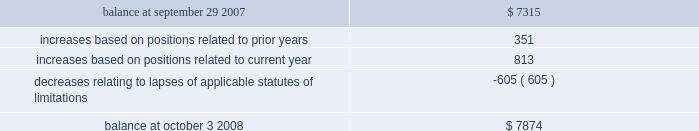Notes to consolidated financial statements 2014 ( continued ) a reconciliation of the beginning and ending amount of gross unrecognized tax benefits is as follows ( in thousands ) : .
The company 2019s major tax jurisdictions as of october 3 , 2008 for fin 48 are the u.s. , california , and iowa .
For the u.s. , the company has open tax years dating back to fiscal year 1998 due to the carryforward of tax attributes .
For california , the company has open tax years dating back to fiscal year 2002 due to the carryforward of tax attributes .
For iowa , the company has open tax years dating back to fiscal year 2002 due to the carryforward of tax attributes .
During the year ended october 3 , 2008 , the statute of limitations period expired relating to an unrecognized tax benefit .
The expiration of the statute of limitations period resulted in the recognition of $ 0.6 million of previously unrecognized tax benefit , which impacted the effective tax rate , and $ 0.5 million of accrued interest related to this tax position was reversed during the year .
Including this reversal , total year-to-date accrued interest related to the company 2019s unrecognized tax benefits was a benefit of $ 0.4 million .
10 .
Stockholders 2019 equity common stock the company is authorized to issue ( 1 ) 525000000 shares of common stock , par value $ 0.25 per share , and ( 2 ) 25000000 shares of preferred stock , without par value .
Holders of the company 2019s common stock are entitled to such dividends as may be declared by the company 2019s board of directors out of funds legally available for such purpose .
Dividends may not be paid on common stock unless all accrued dividends on preferred stock , if any , have been paid or declared and set aside .
In the event of the company 2019s liquidation , dissolution or winding up , the holders of common stock will be entitled to share pro rata in the assets remaining after payment to creditors and after payment of the liquidation preference plus any unpaid dividends to holders of any outstanding preferred stock .
Each holder of the company 2019s common stock is entitled to one vote for each such share outstanding in the holder 2019s name .
No holder of common stock is entitled to cumulate votes in voting for directors .
The company 2019s second amended and restated certificate of incorporation provides that , unless otherwise determined by the company 2019s board of directors , no holder of common stock has any preemptive right to purchase or subscribe for any stock of any class which the company may issue or sell .
In march 2007 , the company repurchased approximately 4.3 million of its common shares for $ 30.1 million as authorized by the company 2019s board of directors .
The company has no publicly disclosed stock repurchase plans .
At october 3 , 2008 , the company had 170322804 shares of common stock issued and 165591830 shares outstanding .
Preferred stock the company 2019s second amended and restated certificate of incorporation permits the company to issue up to 25000000 shares of preferred stock in one or more series and with rights and preferences that may be fixed or designated by the company 2019s board of directors without any further action by the company 2019s stockholders .
The designation , powers , preferences , rights and qualifications , limitations and restrictions of the preferred stock of each skyworks solutions , inc .
2008 annual report %%transmsg*** transmitting job : a51732 pcn : 099000000 ***%%pcmsg|103 |00005|yes|no|03/26/2009 13:34|0|0|page is valid , no graphics -- color : d| .
What would be the total common stock par value if all authorized shares were outstanding? 
Computations: (525000000 * 0.25)
Answer: 131250000.0. 